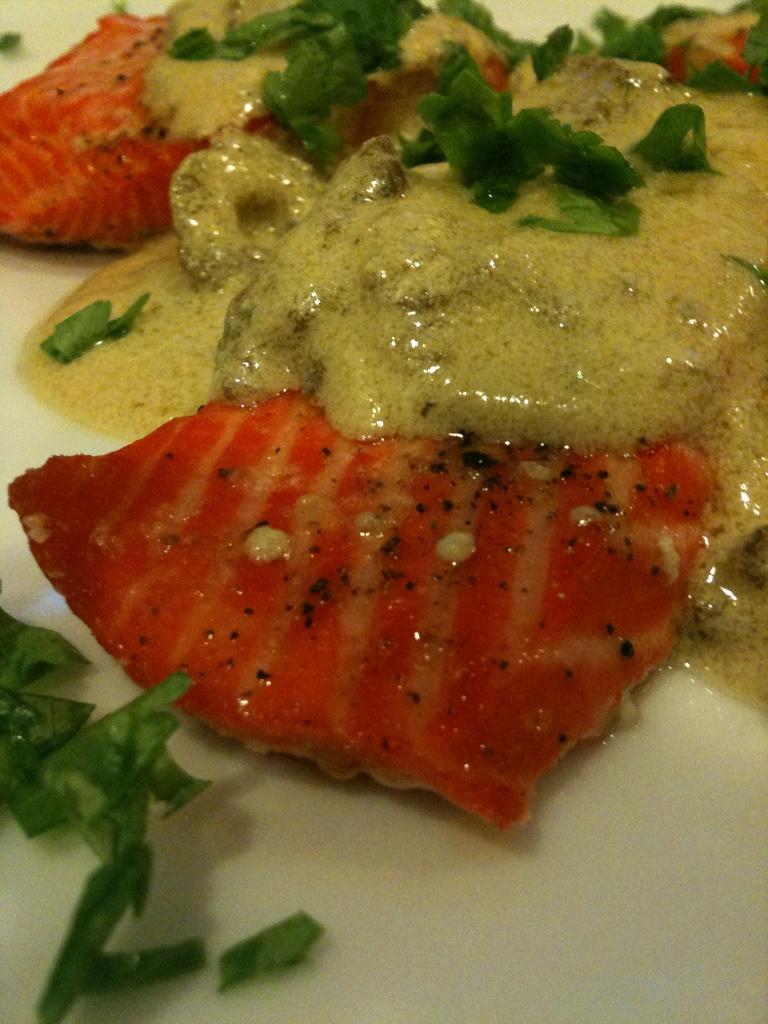Please provide a concise description of this image. In this picture there is an edible placed on a white surface. 